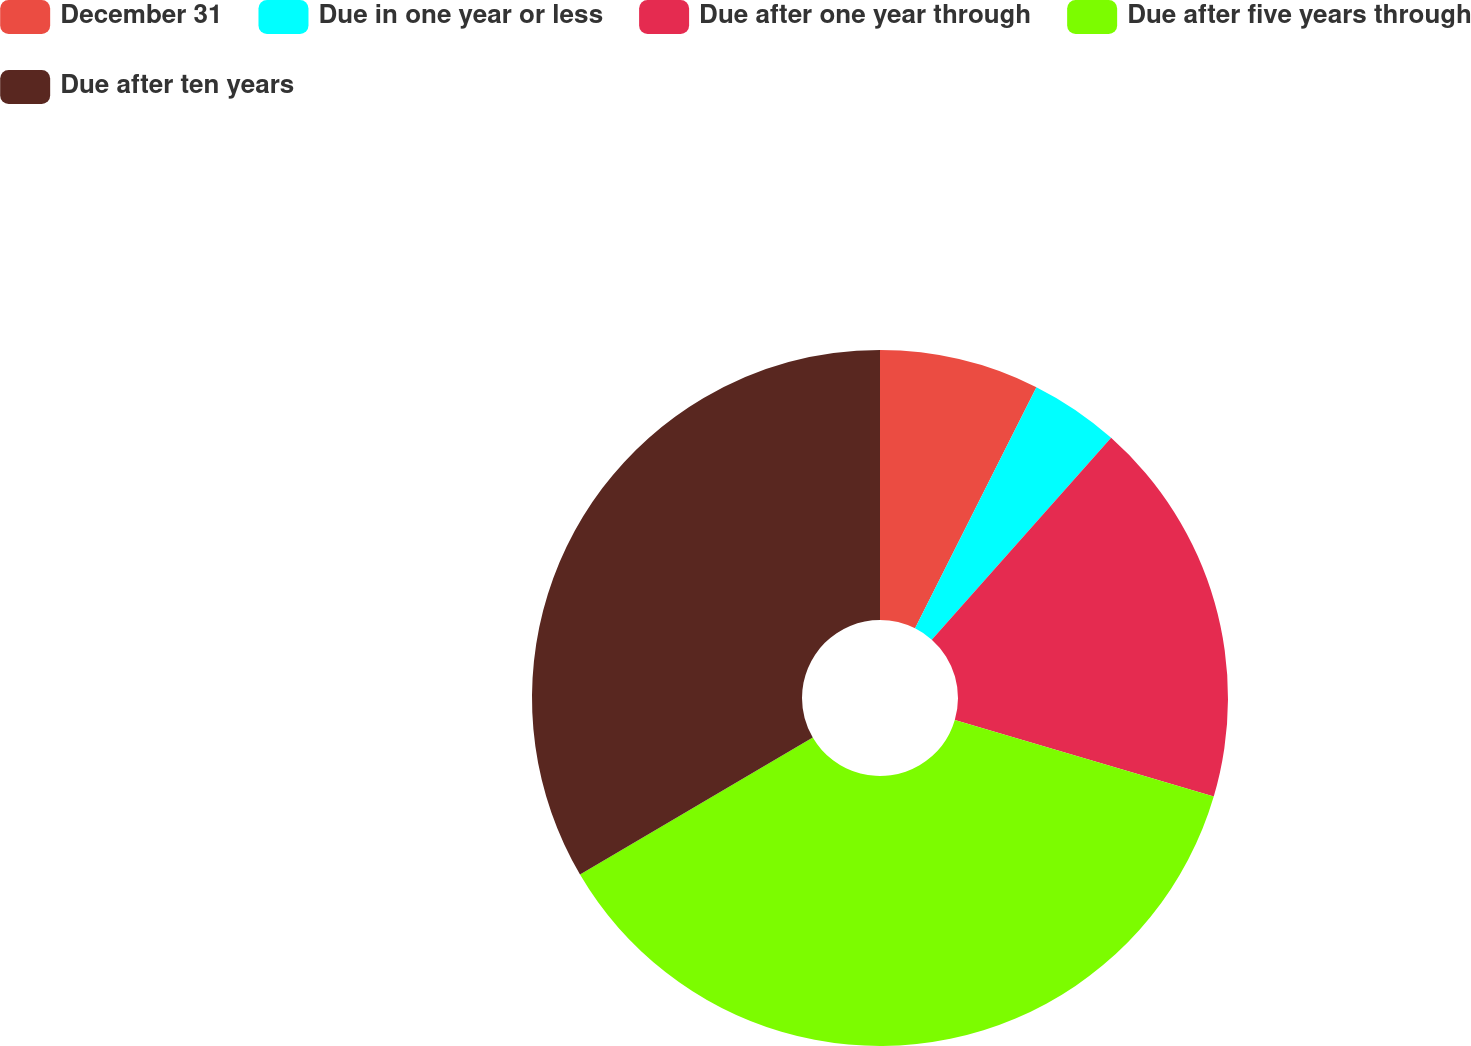<chart> <loc_0><loc_0><loc_500><loc_500><pie_chart><fcel>December 31<fcel>Due in one year or less<fcel>Due after one year through<fcel>Due after five years through<fcel>Due after ten years<nl><fcel>7.42%<fcel>4.14%<fcel>18.01%<fcel>36.97%<fcel>33.46%<nl></chart> 